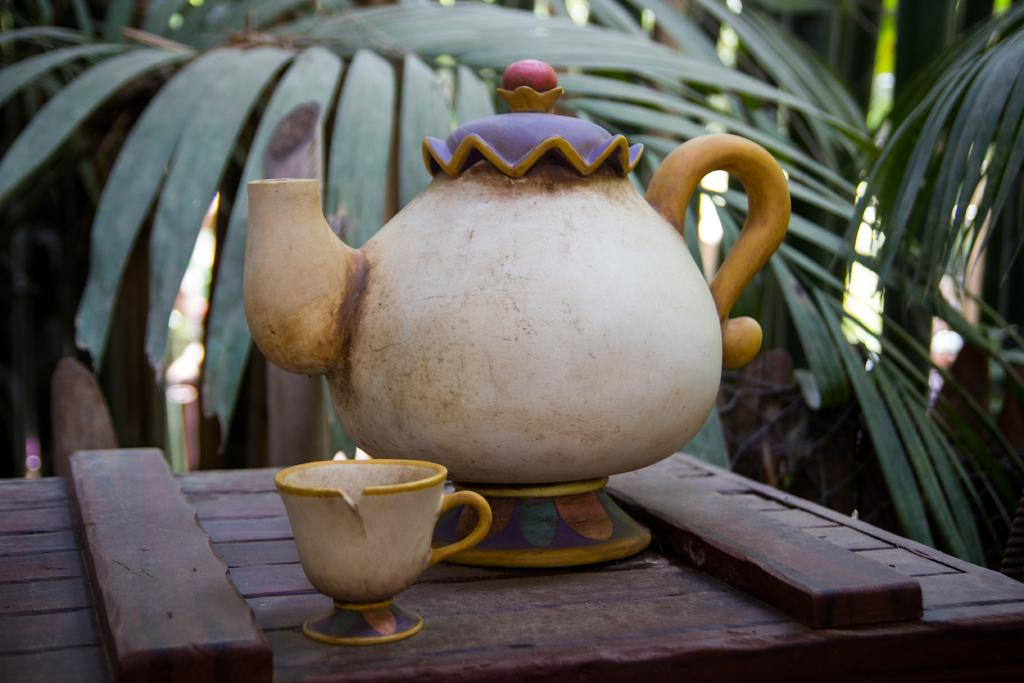What color is the table in the image? The table in the image is brown. What is on the table in the image? There is a white cup and a white jug on the table. What can be seen in the background of the image? There are green plants and trees in the background of the image. Can you see a river flowing behind the trees in the image? There is no river visible in the image; it only shows trees and green plants in the background. 